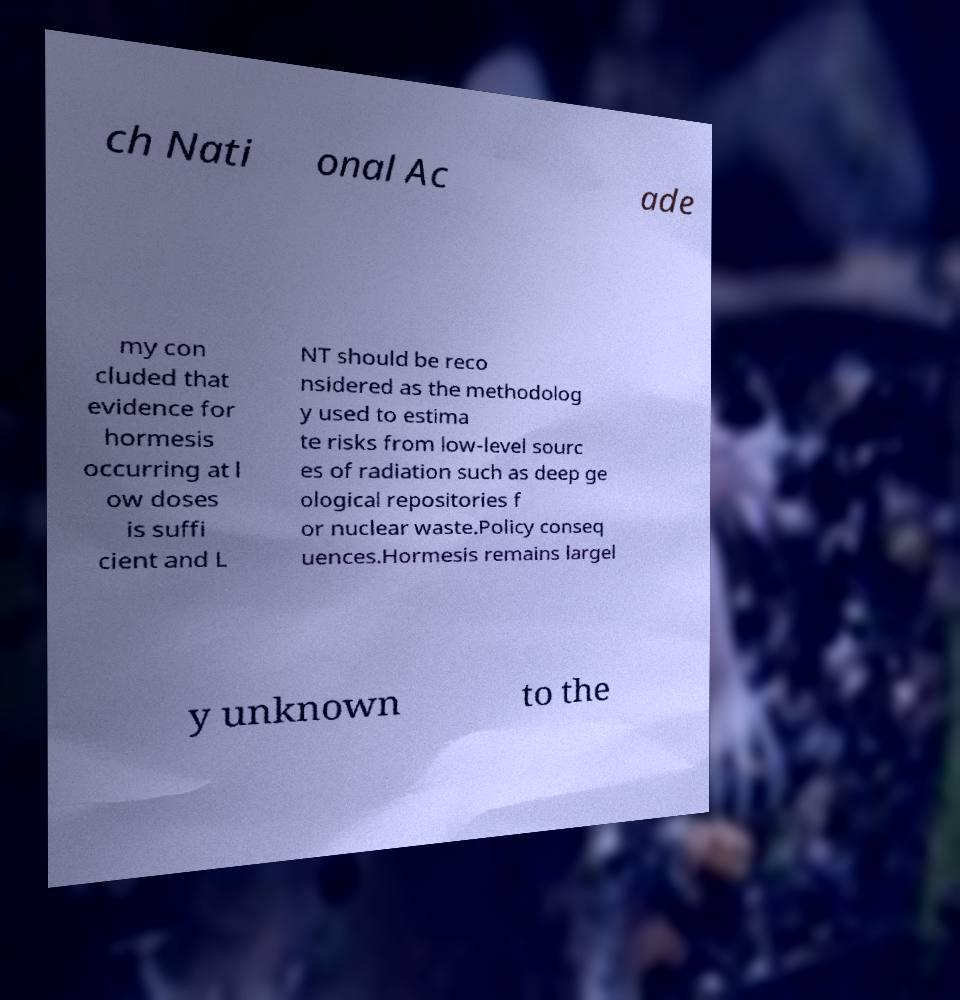Can you accurately transcribe the text from the provided image for me? ch Nati onal Ac ade my con cluded that evidence for hormesis occurring at l ow doses is suffi cient and L NT should be reco nsidered as the methodolog y used to estima te risks from low-level sourc es of radiation such as deep ge ological repositories f or nuclear waste.Policy conseq uences.Hormesis remains largel y unknown to the 